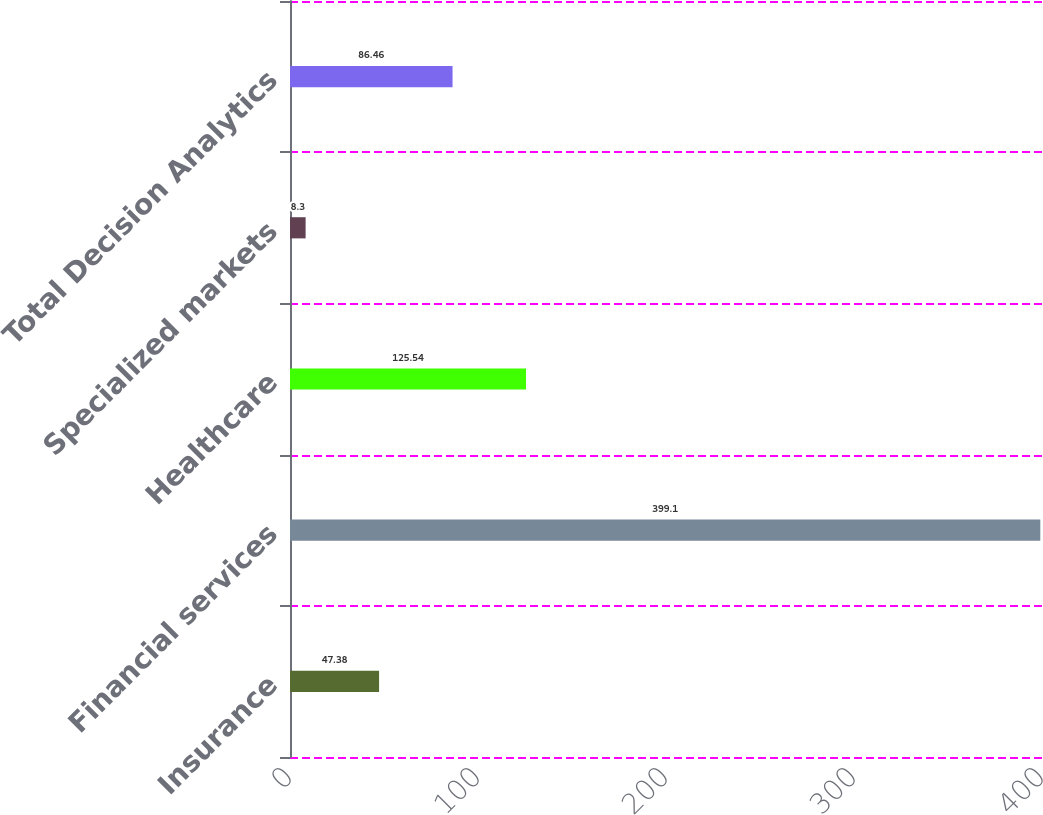Convert chart. <chart><loc_0><loc_0><loc_500><loc_500><bar_chart><fcel>Insurance<fcel>Financial services<fcel>Healthcare<fcel>Specialized markets<fcel>Total Decision Analytics<nl><fcel>47.38<fcel>399.1<fcel>125.54<fcel>8.3<fcel>86.46<nl></chart> 